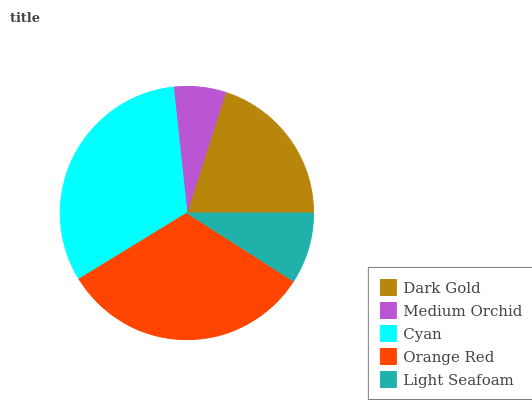Is Medium Orchid the minimum?
Answer yes or no. Yes. Is Orange Red the maximum?
Answer yes or no. Yes. Is Cyan the minimum?
Answer yes or no. No. Is Cyan the maximum?
Answer yes or no. No. Is Cyan greater than Medium Orchid?
Answer yes or no. Yes. Is Medium Orchid less than Cyan?
Answer yes or no. Yes. Is Medium Orchid greater than Cyan?
Answer yes or no. No. Is Cyan less than Medium Orchid?
Answer yes or no. No. Is Dark Gold the high median?
Answer yes or no. Yes. Is Dark Gold the low median?
Answer yes or no. Yes. Is Light Seafoam the high median?
Answer yes or no. No. Is Light Seafoam the low median?
Answer yes or no. No. 